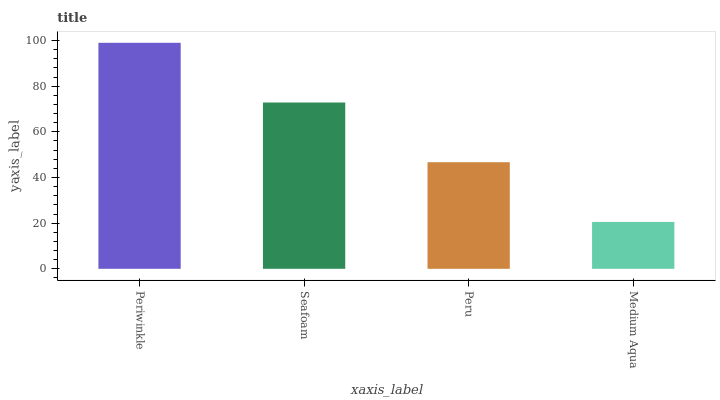Is Medium Aqua the minimum?
Answer yes or no. Yes. Is Periwinkle the maximum?
Answer yes or no. Yes. Is Seafoam the minimum?
Answer yes or no. No. Is Seafoam the maximum?
Answer yes or no. No. Is Periwinkle greater than Seafoam?
Answer yes or no. Yes. Is Seafoam less than Periwinkle?
Answer yes or no. Yes. Is Seafoam greater than Periwinkle?
Answer yes or no. No. Is Periwinkle less than Seafoam?
Answer yes or no. No. Is Seafoam the high median?
Answer yes or no. Yes. Is Peru the low median?
Answer yes or no. Yes. Is Medium Aqua the high median?
Answer yes or no. No. Is Periwinkle the low median?
Answer yes or no. No. 